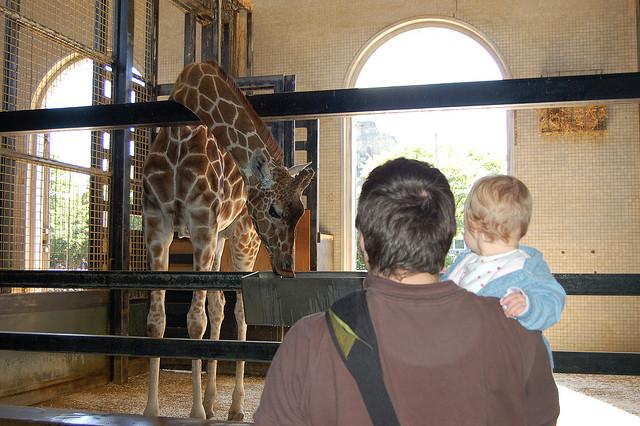When was the photo taken?
Quick response, please. Daytime. Is the giraffe sad?
Write a very short answer. No. Is this a zoo?
Quick response, please. Yes. 